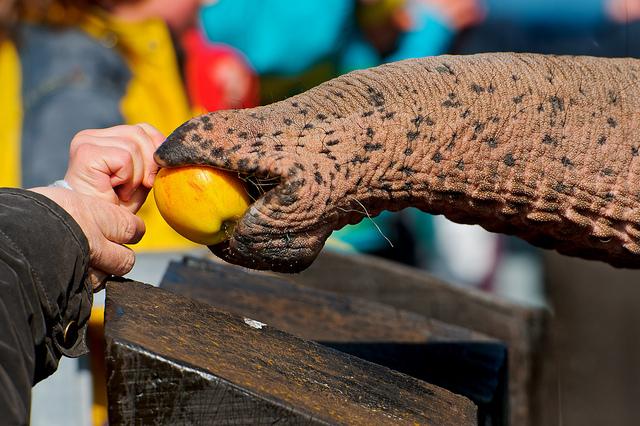What is the animal eating?
Answer briefly. Apple. Is that an apple?
Quick response, please. Yes. What is the animal holding?
Quick response, please. Apple. 